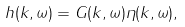Convert formula to latex. <formula><loc_0><loc_0><loc_500><loc_500>h ( { k } , \omega ) = G ( { k } , \omega ) \eta ( { k } , \omega ) ,</formula> 